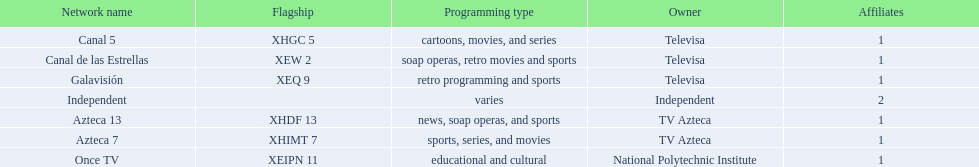Could you parse the entire table? {'header': ['Network name', 'Flagship', 'Programming type', 'Owner', 'Affiliates'], 'rows': [['Canal 5', 'XHGC 5', 'cartoons, movies, and series', 'Televisa', '1'], ['Canal de las Estrellas', 'XEW 2', 'soap operas, retro movies and sports', 'Televisa', '1'], ['Galavisión', 'XEQ 9', 'retro programming and sports', 'Televisa', '1'], ['Independent', '', 'varies', 'Independent', '2'], ['Azteca 13', 'XHDF 13', 'news, soap operas, and sports', 'TV Azteca', '1'], ['Azteca 7', 'XHIMT 7', 'sports, series, and movies', 'TV Azteca', '1'], ['Once TV', 'XEIPN 11', 'educational and cultural', 'National Polytechnic Institute', '1']]} How many networks do not air sports? 2. 